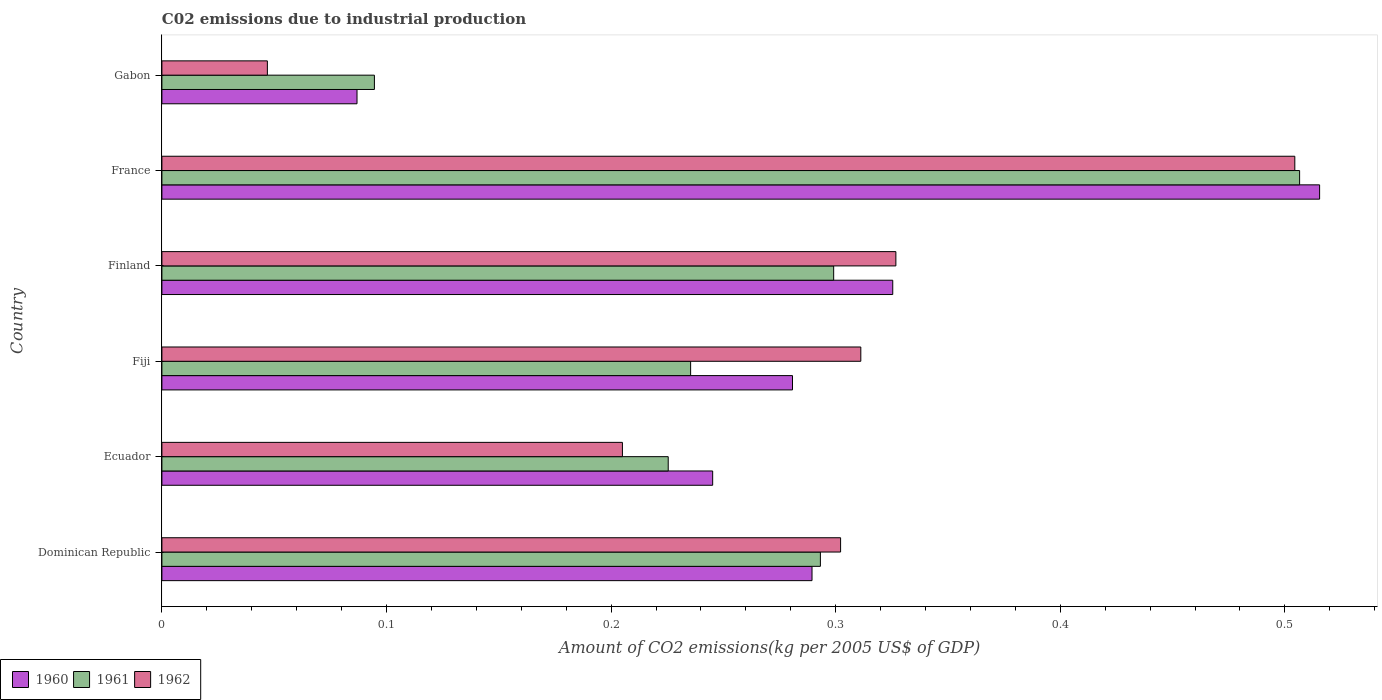How many different coloured bars are there?
Provide a short and direct response. 3. What is the label of the 4th group of bars from the top?
Provide a succinct answer. Fiji. What is the amount of CO2 emitted due to industrial production in 1961 in Finland?
Your response must be concise. 0.3. Across all countries, what is the maximum amount of CO2 emitted due to industrial production in 1962?
Your response must be concise. 0.5. Across all countries, what is the minimum amount of CO2 emitted due to industrial production in 1960?
Your answer should be compact. 0.09. In which country was the amount of CO2 emitted due to industrial production in 1962 minimum?
Offer a terse response. Gabon. What is the total amount of CO2 emitted due to industrial production in 1960 in the graph?
Make the answer very short. 1.74. What is the difference between the amount of CO2 emitted due to industrial production in 1962 in Fiji and that in Finland?
Keep it short and to the point. -0.02. What is the difference between the amount of CO2 emitted due to industrial production in 1960 in Finland and the amount of CO2 emitted due to industrial production in 1962 in Dominican Republic?
Provide a short and direct response. 0.02. What is the average amount of CO2 emitted due to industrial production in 1960 per country?
Your response must be concise. 0.29. What is the difference between the amount of CO2 emitted due to industrial production in 1960 and amount of CO2 emitted due to industrial production in 1962 in Ecuador?
Give a very brief answer. 0.04. What is the ratio of the amount of CO2 emitted due to industrial production in 1961 in Fiji to that in Gabon?
Provide a succinct answer. 2.49. Is the difference between the amount of CO2 emitted due to industrial production in 1960 in Finland and Gabon greater than the difference between the amount of CO2 emitted due to industrial production in 1962 in Finland and Gabon?
Your answer should be very brief. No. What is the difference between the highest and the second highest amount of CO2 emitted due to industrial production in 1960?
Offer a very short reply. 0.19. What is the difference between the highest and the lowest amount of CO2 emitted due to industrial production in 1960?
Your answer should be compact. 0.43. In how many countries, is the amount of CO2 emitted due to industrial production in 1962 greater than the average amount of CO2 emitted due to industrial production in 1962 taken over all countries?
Your response must be concise. 4. Is it the case that in every country, the sum of the amount of CO2 emitted due to industrial production in 1962 and amount of CO2 emitted due to industrial production in 1961 is greater than the amount of CO2 emitted due to industrial production in 1960?
Offer a very short reply. Yes. How many bars are there?
Ensure brevity in your answer.  18. What is the difference between two consecutive major ticks on the X-axis?
Give a very brief answer. 0.1. How many legend labels are there?
Provide a succinct answer. 3. How are the legend labels stacked?
Your answer should be very brief. Horizontal. What is the title of the graph?
Ensure brevity in your answer.  C02 emissions due to industrial production. What is the label or title of the X-axis?
Ensure brevity in your answer.  Amount of CO2 emissions(kg per 2005 US$ of GDP). What is the Amount of CO2 emissions(kg per 2005 US$ of GDP) of 1960 in Dominican Republic?
Ensure brevity in your answer.  0.29. What is the Amount of CO2 emissions(kg per 2005 US$ of GDP) in 1961 in Dominican Republic?
Keep it short and to the point. 0.29. What is the Amount of CO2 emissions(kg per 2005 US$ of GDP) in 1962 in Dominican Republic?
Offer a very short reply. 0.3. What is the Amount of CO2 emissions(kg per 2005 US$ of GDP) in 1960 in Ecuador?
Offer a very short reply. 0.25. What is the Amount of CO2 emissions(kg per 2005 US$ of GDP) of 1961 in Ecuador?
Give a very brief answer. 0.23. What is the Amount of CO2 emissions(kg per 2005 US$ of GDP) of 1962 in Ecuador?
Your response must be concise. 0.21. What is the Amount of CO2 emissions(kg per 2005 US$ of GDP) of 1960 in Fiji?
Keep it short and to the point. 0.28. What is the Amount of CO2 emissions(kg per 2005 US$ of GDP) in 1961 in Fiji?
Keep it short and to the point. 0.24. What is the Amount of CO2 emissions(kg per 2005 US$ of GDP) in 1962 in Fiji?
Your answer should be very brief. 0.31. What is the Amount of CO2 emissions(kg per 2005 US$ of GDP) of 1960 in Finland?
Your answer should be very brief. 0.33. What is the Amount of CO2 emissions(kg per 2005 US$ of GDP) in 1961 in Finland?
Keep it short and to the point. 0.3. What is the Amount of CO2 emissions(kg per 2005 US$ of GDP) in 1962 in Finland?
Ensure brevity in your answer.  0.33. What is the Amount of CO2 emissions(kg per 2005 US$ of GDP) in 1960 in France?
Give a very brief answer. 0.52. What is the Amount of CO2 emissions(kg per 2005 US$ of GDP) of 1961 in France?
Offer a very short reply. 0.51. What is the Amount of CO2 emissions(kg per 2005 US$ of GDP) of 1962 in France?
Offer a terse response. 0.5. What is the Amount of CO2 emissions(kg per 2005 US$ of GDP) in 1960 in Gabon?
Keep it short and to the point. 0.09. What is the Amount of CO2 emissions(kg per 2005 US$ of GDP) of 1961 in Gabon?
Provide a short and direct response. 0.09. What is the Amount of CO2 emissions(kg per 2005 US$ of GDP) of 1962 in Gabon?
Ensure brevity in your answer.  0.05. Across all countries, what is the maximum Amount of CO2 emissions(kg per 2005 US$ of GDP) in 1960?
Offer a terse response. 0.52. Across all countries, what is the maximum Amount of CO2 emissions(kg per 2005 US$ of GDP) in 1961?
Your answer should be very brief. 0.51. Across all countries, what is the maximum Amount of CO2 emissions(kg per 2005 US$ of GDP) of 1962?
Keep it short and to the point. 0.5. Across all countries, what is the minimum Amount of CO2 emissions(kg per 2005 US$ of GDP) of 1960?
Your answer should be very brief. 0.09. Across all countries, what is the minimum Amount of CO2 emissions(kg per 2005 US$ of GDP) in 1961?
Your answer should be very brief. 0.09. Across all countries, what is the minimum Amount of CO2 emissions(kg per 2005 US$ of GDP) in 1962?
Your response must be concise. 0.05. What is the total Amount of CO2 emissions(kg per 2005 US$ of GDP) of 1960 in the graph?
Offer a terse response. 1.74. What is the total Amount of CO2 emissions(kg per 2005 US$ of GDP) in 1961 in the graph?
Give a very brief answer. 1.65. What is the total Amount of CO2 emissions(kg per 2005 US$ of GDP) of 1962 in the graph?
Give a very brief answer. 1.7. What is the difference between the Amount of CO2 emissions(kg per 2005 US$ of GDP) in 1960 in Dominican Republic and that in Ecuador?
Your answer should be very brief. 0.04. What is the difference between the Amount of CO2 emissions(kg per 2005 US$ of GDP) of 1961 in Dominican Republic and that in Ecuador?
Ensure brevity in your answer.  0.07. What is the difference between the Amount of CO2 emissions(kg per 2005 US$ of GDP) of 1962 in Dominican Republic and that in Ecuador?
Your response must be concise. 0.1. What is the difference between the Amount of CO2 emissions(kg per 2005 US$ of GDP) in 1960 in Dominican Republic and that in Fiji?
Your answer should be very brief. 0.01. What is the difference between the Amount of CO2 emissions(kg per 2005 US$ of GDP) of 1961 in Dominican Republic and that in Fiji?
Your answer should be very brief. 0.06. What is the difference between the Amount of CO2 emissions(kg per 2005 US$ of GDP) of 1962 in Dominican Republic and that in Fiji?
Your response must be concise. -0.01. What is the difference between the Amount of CO2 emissions(kg per 2005 US$ of GDP) in 1960 in Dominican Republic and that in Finland?
Ensure brevity in your answer.  -0.04. What is the difference between the Amount of CO2 emissions(kg per 2005 US$ of GDP) of 1961 in Dominican Republic and that in Finland?
Provide a short and direct response. -0.01. What is the difference between the Amount of CO2 emissions(kg per 2005 US$ of GDP) of 1962 in Dominican Republic and that in Finland?
Provide a short and direct response. -0.02. What is the difference between the Amount of CO2 emissions(kg per 2005 US$ of GDP) of 1960 in Dominican Republic and that in France?
Offer a terse response. -0.23. What is the difference between the Amount of CO2 emissions(kg per 2005 US$ of GDP) of 1961 in Dominican Republic and that in France?
Keep it short and to the point. -0.21. What is the difference between the Amount of CO2 emissions(kg per 2005 US$ of GDP) in 1962 in Dominican Republic and that in France?
Keep it short and to the point. -0.2. What is the difference between the Amount of CO2 emissions(kg per 2005 US$ of GDP) in 1960 in Dominican Republic and that in Gabon?
Your response must be concise. 0.2. What is the difference between the Amount of CO2 emissions(kg per 2005 US$ of GDP) of 1961 in Dominican Republic and that in Gabon?
Provide a succinct answer. 0.2. What is the difference between the Amount of CO2 emissions(kg per 2005 US$ of GDP) of 1962 in Dominican Republic and that in Gabon?
Keep it short and to the point. 0.26. What is the difference between the Amount of CO2 emissions(kg per 2005 US$ of GDP) of 1960 in Ecuador and that in Fiji?
Provide a short and direct response. -0.04. What is the difference between the Amount of CO2 emissions(kg per 2005 US$ of GDP) of 1961 in Ecuador and that in Fiji?
Your answer should be very brief. -0.01. What is the difference between the Amount of CO2 emissions(kg per 2005 US$ of GDP) in 1962 in Ecuador and that in Fiji?
Your response must be concise. -0.11. What is the difference between the Amount of CO2 emissions(kg per 2005 US$ of GDP) of 1960 in Ecuador and that in Finland?
Provide a short and direct response. -0.08. What is the difference between the Amount of CO2 emissions(kg per 2005 US$ of GDP) in 1961 in Ecuador and that in Finland?
Your response must be concise. -0.07. What is the difference between the Amount of CO2 emissions(kg per 2005 US$ of GDP) of 1962 in Ecuador and that in Finland?
Your answer should be very brief. -0.12. What is the difference between the Amount of CO2 emissions(kg per 2005 US$ of GDP) of 1960 in Ecuador and that in France?
Make the answer very short. -0.27. What is the difference between the Amount of CO2 emissions(kg per 2005 US$ of GDP) of 1961 in Ecuador and that in France?
Make the answer very short. -0.28. What is the difference between the Amount of CO2 emissions(kg per 2005 US$ of GDP) of 1962 in Ecuador and that in France?
Your answer should be very brief. -0.3. What is the difference between the Amount of CO2 emissions(kg per 2005 US$ of GDP) of 1960 in Ecuador and that in Gabon?
Give a very brief answer. 0.16. What is the difference between the Amount of CO2 emissions(kg per 2005 US$ of GDP) in 1961 in Ecuador and that in Gabon?
Keep it short and to the point. 0.13. What is the difference between the Amount of CO2 emissions(kg per 2005 US$ of GDP) of 1962 in Ecuador and that in Gabon?
Provide a short and direct response. 0.16. What is the difference between the Amount of CO2 emissions(kg per 2005 US$ of GDP) in 1960 in Fiji and that in Finland?
Keep it short and to the point. -0.04. What is the difference between the Amount of CO2 emissions(kg per 2005 US$ of GDP) of 1961 in Fiji and that in Finland?
Ensure brevity in your answer.  -0.06. What is the difference between the Amount of CO2 emissions(kg per 2005 US$ of GDP) of 1962 in Fiji and that in Finland?
Your answer should be very brief. -0.02. What is the difference between the Amount of CO2 emissions(kg per 2005 US$ of GDP) of 1960 in Fiji and that in France?
Offer a very short reply. -0.23. What is the difference between the Amount of CO2 emissions(kg per 2005 US$ of GDP) of 1961 in Fiji and that in France?
Ensure brevity in your answer.  -0.27. What is the difference between the Amount of CO2 emissions(kg per 2005 US$ of GDP) in 1962 in Fiji and that in France?
Keep it short and to the point. -0.19. What is the difference between the Amount of CO2 emissions(kg per 2005 US$ of GDP) of 1960 in Fiji and that in Gabon?
Ensure brevity in your answer.  0.19. What is the difference between the Amount of CO2 emissions(kg per 2005 US$ of GDP) in 1961 in Fiji and that in Gabon?
Provide a succinct answer. 0.14. What is the difference between the Amount of CO2 emissions(kg per 2005 US$ of GDP) of 1962 in Fiji and that in Gabon?
Offer a terse response. 0.26. What is the difference between the Amount of CO2 emissions(kg per 2005 US$ of GDP) of 1960 in Finland and that in France?
Ensure brevity in your answer.  -0.19. What is the difference between the Amount of CO2 emissions(kg per 2005 US$ of GDP) in 1961 in Finland and that in France?
Offer a terse response. -0.21. What is the difference between the Amount of CO2 emissions(kg per 2005 US$ of GDP) of 1962 in Finland and that in France?
Ensure brevity in your answer.  -0.18. What is the difference between the Amount of CO2 emissions(kg per 2005 US$ of GDP) in 1960 in Finland and that in Gabon?
Your answer should be very brief. 0.24. What is the difference between the Amount of CO2 emissions(kg per 2005 US$ of GDP) in 1961 in Finland and that in Gabon?
Provide a succinct answer. 0.2. What is the difference between the Amount of CO2 emissions(kg per 2005 US$ of GDP) of 1962 in Finland and that in Gabon?
Provide a succinct answer. 0.28. What is the difference between the Amount of CO2 emissions(kg per 2005 US$ of GDP) in 1960 in France and that in Gabon?
Offer a terse response. 0.43. What is the difference between the Amount of CO2 emissions(kg per 2005 US$ of GDP) in 1961 in France and that in Gabon?
Make the answer very short. 0.41. What is the difference between the Amount of CO2 emissions(kg per 2005 US$ of GDP) of 1962 in France and that in Gabon?
Ensure brevity in your answer.  0.46. What is the difference between the Amount of CO2 emissions(kg per 2005 US$ of GDP) of 1960 in Dominican Republic and the Amount of CO2 emissions(kg per 2005 US$ of GDP) of 1961 in Ecuador?
Keep it short and to the point. 0.06. What is the difference between the Amount of CO2 emissions(kg per 2005 US$ of GDP) in 1960 in Dominican Republic and the Amount of CO2 emissions(kg per 2005 US$ of GDP) in 1962 in Ecuador?
Offer a very short reply. 0.08. What is the difference between the Amount of CO2 emissions(kg per 2005 US$ of GDP) of 1961 in Dominican Republic and the Amount of CO2 emissions(kg per 2005 US$ of GDP) of 1962 in Ecuador?
Give a very brief answer. 0.09. What is the difference between the Amount of CO2 emissions(kg per 2005 US$ of GDP) in 1960 in Dominican Republic and the Amount of CO2 emissions(kg per 2005 US$ of GDP) in 1961 in Fiji?
Offer a very short reply. 0.05. What is the difference between the Amount of CO2 emissions(kg per 2005 US$ of GDP) in 1960 in Dominican Republic and the Amount of CO2 emissions(kg per 2005 US$ of GDP) in 1962 in Fiji?
Provide a short and direct response. -0.02. What is the difference between the Amount of CO2 emissions(kg per 2005 US$ of GDP) of 1961 in Dominican Republic and the Amount of CO2 emissions(kg per 2005 US$ of GDP) of 1962 in Fiji?
Ensure brevity in your answer.  -0.02. What is the difference between the Amount of CO2 emissions(kg per 2005 US$ of GDP) of 1960 in Dominican Republic and the Amount of CO2 emissions(kg per 2005 US$ of GDP) of 1961 in Finland?
Keep it short and to the point. -0.01. What is the difference between the Amount of CO2 emissions(kg per 2005 US$ of GDP) of 1960 in Dominican Republic and the Amount of CO2 emissions(kg per 2005 US$ of GDP) of 1962 in Finland?
Your response must be concise. -0.04. What is the difference between the Amount of CO2 emissions(kg per 2005 US$ of GDP) in 1961 in Dominican Republic and the Amount of CO2 emissions(kg per 2005 US$ of GDP) in 1962 in Finland?
Offer a terse response. -0.03. What is the difference between the Amount of CO2 emissions(kg per 2005 US$ of GDP) in 1960 in Dominican Republic and the Amount of CO2 emissions(kg per 2005 US$ of GDP) in 1961 in France?
Give a very brief answer. -0.22. What is the difference between the Amount of CO2 emissions(kg per 2005 US$ of GDP) of 1960 in Dominican Republic and the Amount of CO2 emissions(kg per 2005 US$ of GDP) of 1962 in France?
Offer a very short reply. -0.21. What is the difference between the Amount of CO2 emissions(kg per 2005 US$ of GDP) in 1961 in Dominican Republic and the Amount of CO2 emissions(kg per 2005 US$ of GDP) in 1962 in France?
Offer a very short reply. -0.21. What is the difference between the Amount of CO2 emissions(kg per 2005 US$ of GDP) in 1960 in Dominican Republic and the Amount of CO2 emissions(kg per 2005 US$ of GDP) in 1961 in Gabon?
Ensure brevity in your answer.  0.19. What is the difference between the Amount of CO2 emissions(kg per 2005 US$ of GDP) of 1960 in Dominican Republic and the Amount of CO2 emissions(kg per 2005 US$ of GDP) of 1962 in Gabon?
Ensure brevity in your answer.  0.24. What is the difference between the Amount of CO2 emissions(kg per 2005 US$ of GDP) of 1961 in Dominican Republic and the Amount of CO2 emissions(kg per 2005 US$ of GDP) of 1962 in Gabon?
Your response must be concise. 0.25. What is the difference between the Amount of CO2 emissions(kg per 2005 US$ of GDP) of 1960 in Ecuador and the Amount of CO2 emissions(kg per 2005 US$ of GDP) of 1961 in Fiji?
Provide a short and direct response. 0.01. What is the difference between the Amount of CO2 emissions(kg per 2005 US$ of GDP) in 1960 in Ecuador and the Amount of CO2 emissions(kg per 2005 US$ of GDP) in 1962 in Fiji?
Your answer should be compact. -0.07. What is the difference between the Amount of CO2 emissions(kg per 2005 US$ of GDP) in 1961 in Ecuador and the Amount of CO2 emissions(kg per 2005 US$ of GDP) in 1962 in Fiji?
Ensure brevity in your answer.  -0.09. What is the difference between the Amount of CO2 emissions(kg per 2005 US$ of GDP) of 1960 in Ecuador and the Amount of CO2 emissions(kg per 2005 US$ of GDP) of 1961 in Finland?
Offer a terse response. -0.05. What is the difference between the Amount of CO2 emissions(kg per 2005 US$ of GDP) of 1960 in Ecuador and the Amount of CO2 emissions(kg per 2005 US$ of GDP) of 1962 in Finland?
Your answer should be compact. -0.08. What is the difference between the Amount of CO2 emissions(kg per 2005 US$ of GDP) of 1961 in Ecuador and the Amount of CO2 emissions(kg per 2005 US$ of GDP) of 1962 in Finland?
Your answer should be very brief. -0.1. What is the difference between the Amount of CO2 emissions(kg per 2005 US$ of GDP) in 1960 in Ecuador and the Amount of CO2 emissions(kg per 2005 US$ of GDP) in 1961 in France?
Provide a succinct answer. -0.26. What is the difference between the Amount of CO2 emissions(kg per 2005 US$ of GDP) of 1960 in Ecuador and the Amount of CO2 emissions(kg per 2005 US$ of GDP) of 1962 in France?
Your answer should be compact. -0.26. What is the difference between the Amount of CO2 emissions(kg per 2005 US$ of GDP) of 1961 in Ecuador and the Amount of CO2 emissions(kg per 2005 US$ of GDP) of 1962 in France?
Your answer should be very brief. -0.28. What is the difference between the Amount of CO2 emissions(kg per 2005 US$ of GDP) of 1960 in Ecuador and the Amount of CO2 emissions(kg per 2005 US$ of GDP) of 1961 in Gabon?
Ensure brevity in your answer.  0.15. What is the difference between the Amount of CO2 emissions(kg per 2005 US$ of GDP) in 1960 in Ecuador and the Amount of CO2 emissions(kg per 2005 US$ of GDP) in 1962 in Gabon?
Keep it short and to the point. 0.2. What is the difference between the Amount of CO2 emissions(kg per 2005 US$ of GDP) of 1961 in Ecuador and the Amount of CO2 emissions(kg per 2005 US$ of GDP) of 1962 in Gabon?
Give a very brief answer. 0.18. What is the difference between the Amount of CO2 emissions(kg per 2005 US$ of GDP) of 1960 in Fiji and the Amount of CO2 emissions(kg per 2005 US$ of GDP) of 1961 in Finland?
Give a very brief answer. -0.02. What is the difference between the Amount of CO2 emissions(kg per 2005 US$ of GDP) in 1960 in Fiji and the Amount of CO2 emissions(kg per 2005 US$ of GDP) in 1962 in Finland?
Offer a terse response. -0.05. What is the difference between the Amount of CO2 emissions(kg per 2005 US$ of GDP) of 1961 in Fiji and the Amount of CO2 emissions(kg per 2005 US$ of GDP) of 1962 in Finland?
Keep it short and to the point. -0.09. What is the difference between the Amount of CO2 emissions(kg per 2005 US$ of GDP) in 1960 in Fiji and the Amount of CO2 emissions(kg per 2005 US$ of GDP) in 1961 in France?
Give a very brief answer. -0.23. What is the difference between the Amount of CO2 emissions(kg per 2005 US$ of GDP) of 1960 in Fiji and the Amount of CO2 emissions(kg per 2005 US$ of GDP) of 1962 in France?
Offer a terse response. -0.22. What is the difference between the Amount of CO2 emissions(kg per 2005 US$ of GDP) in 1961 in Fiji and the Amount of CO2 emissions(kg per 2005 US$ of GDP) in 1962 in France?
Ensure brevity in your answer.  -0.27. What is the difference between the Amount of CO2 emissions(kg per 2005 US$ of GDP) in 1960 in Fiji and the Amount of CO2 emissions(kg per 2005 US$ of GDP) in 1961 in Gabon?
Give a very brief answer. 0.19. What is the difference between the Amount of CO2 emissions(kg per 2005 US$ of GDP) in 1960 in Fiji and the Amount of CO2 emissions(kg per 2005 US$ of GDP) in 1962 in Gabon?
Offer a terse response. 0.23. What is the difference between the Amount of CO2 emissions(kg per 2005 US$ of GDP) in 1961 in Fiji and the Amount of CO2 emissions(kg per 2005 US$ of GDP) in 1962 in Gabon?
Your response must be concise. 0.19. What is the difference between the Amount of CO2 emissions(kg per 2005 US$ of GDP) of 1960 in Finland and the Amount of CO2 emissions(kg per 2005 US$ of GDP) of 1961 in France?
Give a very brief answer. -0.18. What is the difference between the Amount of CO2 emissions(kg per 2005 US$ of GDP) in 1960 in Finland and the Amount of CO2 emissions(kg per 2005 US$ of GDP) in 1962 in France?
Keep it short and to the point. -0.18. What is the difference between the Amount of CO2 emissions(kg per 2005 US$ of GDP) in 1961 in Finland and the Amount of CO2 emissions(kg per 2005 US$ of GDP) in 1962 in France?
Provide a short and direct response. -0.21. What is the difference between the Amount of CO2 emissions(kg per 2005 US$ of GDP) of 1960 in Finland and the Amount of CO2 emissions(kg per 2005 US$ of GDP) of 1961 in Gabon?
Provide a short and direct response. 0.23. What is the difference between the Amount of CO2 emissions(kg per 2005 US$ of GDP) in 1960 in Finland and the Amount of CO2 emissions(kg per 2005 US$ of GDP) in 1962 in Gabon?
Ensure brevity in your answer.  0.28. What is the difference between the Amount of CO2 emissions(kg per 2005 US$ of GDP) in 1961 in Finland and the Amount of CO2 emissions(kg per 2005 US$ of GDP) in 1962 in Gabon?
Provide a short and direct response. 0.25. What is the difference between the Amount of CO2 emissions(kg per 2005 US$ of GDP) of 1960 in France and the Amount of CO2 emissions(kg per 2005 US$ of GDP) of 1961 in Gabon?
Your response must be concise. 0.42. What is the difference between the Amount of CO2 emissions(kg per 2005 US$ of GDP) in 1960 in France and the Amount of CO2 emissions(kg per 2005 US$ of GDP) in 1962 in Gabon?
Provide a short and direct response. 0.47. What is the difference between the Amount of CO2 emissions(kg per 2005 US$ of GDP) of 1961 in France and the Amount of CO2 emissions(kg per 2005 US$ of GDP) of 1962 in Gabon?
Give a very brief answer. 0.46. What is the average Amount of CO2 emissions(kg per 2005 US$ of GDP) in 1960 per country?
Offer a terse response. 0.29. What is the average Amount of CO2 emissions(kg per 2005 US$ of GDP) in 1961 per country?
Keep it short and to the point. 0.28. What is the average Amount of CO2 emissions(kg per 2005 US$ of GDP) in 1962 per country?
Give a very brief answer. 0.28. What is the difference between the Amount of CO2 emissions(kg per 2005 US$ of GDP) in 1960 and Amount of CO2 emissions(kg per 2005 US$ of GDP) in 1961 in Dominican Republic?
Your answer should be compact. -0. What is the difference between the Amount of CO2 emissions(kg per 2005 US$ of GDP) in 1960 and Amount of CO2 emissions(kg per 2005 US$ of GDP) in 1962 in Dominican Republic?
Offer a terse response. -0.01. What is the difference between the Amount of CO2 emissions(kg per 2005 US$ of GDP) of 1961 and Amount of CO2 emissions(kg per 2005 US$ of GDP) of 1962 in Dominican Republic?
Ensure brevity in your answer.  -0.01. What is the difference between the Amount of CO2 emissions(kg per 2005 US$ of GDP) of 1960 and Amount of CO2 emissions(kg per 2005 US$ of GDP) of 1961 in Ecuador?
Ensure brevity in your answer.  0.02. What is the difference between the Amount of CO2 emissions(kg per 2005 US$ of GDP) in 1960 and Amount of CO2 emissions(kg per 2005 US$ of GDP) in 1962 in Ecuador?
Give a very brief answer. 0.04. What is the difference between the Amount of CO2 emissions(kg per 2005 US$ of GDP) in 1961 and Amount of CO2 emissions(kg per 2005 US$ of GDP) in 1962 in Ecuador?
Keep it short and to the point. 0.02. What is the difference between the Amount of CO2 emissions(kg per 2005 US$ of GDP) of 1960 and Amount of CO2 emissions(kg per 2005 US$ of GDP) of 1961 in Fiji?
Offer a terse response. 0.05. What is the difference between the Amount of CO2 emissions(kg per 2005 US$ of GDP) of 1960 and Amount of CO2 emissions(kg per 2005 US$ of GDP) of 1962 in Fiji?
Make the answer very short. -0.03. What is the difference between the Amount of CO2 emissions(kg per 2005 US$ of GDP) of 1961 and Amount of CO2 emissions(kg per 2005 US$ of GDP) of 1962 in Fiji?
Make the answer very short. -0.08. What is the difference between the Amount of CO2 emissions(kg per 2005 US$ of GDP) in 1960 and Amount of CO2 emissions(kg per 2005 US$ of GDP) in 1961 in Finland?
Provide a short and direct response. 0.03. What is the difference between the Amount of CO2 emissions(kg per 2005 US$ of GDP) in 1960 and Amount of CO2 emissions(kg per 2005 US$ of GDP) in 1962 in Finland?
Offer a terse response. -0. What is the difference between the Amount of CO2 emissions(kg per 2005 US$ of GDP) of 1961 and Amount of CO2 emissions(kg per 2005 US$ of GDP) of 1962 in Finland?
Offer a very short reply. -0.03. What is the difference between the Amount of CO2 emissions(kg per 2005 US$ of GDP) in 1960 and Amount of CO2 emissions(kg per 2005 US$ of GDP) in 1961 in France?
Your answer should be very brief. 0.01. What is the difference between the Amount of CO2 emissions(kg per 2005 US$ of GDP) of 1960 and Amount of CO2 emissions(kg per 2005 US$ of GDP) of 1962 in France?
Offer a very short reply. 0.01. What is the difference between the Amount of CO2 emissions(kg per 2005 US$ of GDP) in 1961 and Amount of CO2 emissions(kg per 2005 US$ of GDP) in 1962 in France?
Your answer should be very brief. 0. What is the difference between the Amount of CO2 emissions(kg per 2005 US$ of GDP) in 1960 and Amount of CO2 emissions(kg per 2005 US$ of GDP) in 1961 in Gabon?
Ensure brevity in your answer.  -0.01. What is the difference between the Amount of CO2 emissions(kg per 2005 US$ of GDP) in 1960 and Amount of CO2 emissions(kg per 2005 US$ of GDP) in 1962 in Gabon?
Your response must be concise. 0.04. What is the difference between the Amount of CO2 emissions(kg per 2005 US$ of GDP) of 1961 and Amount of CO2 emissions(kg per 2005 US$ of GDP) of 1962 in Gabon?
Offer a very short reply. 0.05. What is the ratio of the Amount of CO2 emissions(kg per 2005 US$ of GDP) in 1960 in Dominican Republic to that in Ecuador?
Your answer should be very brief. 1.18. What is the ratio of the Amount of CO2 emissions(kg per 2005 US$ of GDP) in 1961 in Dominican Republic to that in Ecuador?
Make the answer very short. 1.3. What is the ratio of the Amount of CO2 emissions(kg per 2005 US$ of GDP) of 1962 in Dominican Republic to that in Ecuador?
Offer a terse response. 1.47. What is the ratio of the Amount of CO2 emissions(kg per 2005 US$ of GDP) in 1960 in Dominican Republic to that in Fiji?
Your answer should be very brief. 1.03. What is the ratio of the Amount of CO2 emissions(kg per 2005 US$ of GDP) in 1961 in Dominican Republic to that in Fiji?
Offer a very short reply. 1.25. What is the ratio of the Amount of CO2 emissions(kg per 2005 US$ of GDP) in 1962 in Dominican Republic to that in Fiji?
Make the answer very short. 0.97. What is the ratio of the Amount of CO2 emissions(kg per 2005 US$ of GDP) of 1960 in Dominican Republic to that in Finland?
Offer a terse response. 0.89. What is the ratio of the Amount of CO2 emissions(kg per 2005 US$ of GDP) of 1961 in Dominican Republic to that in Finland?
Provide a succinct answer. 0.98. What is the ratio of the Amount of CO2 emissions(kg per 2005 US$ of GDP) in 1962 in Dominican Republic to that in Finland?
Keep it short and to the point. 0.92. What is the ratio of the Amount of CO2 emissions(kg per 2005 US$ of GDP) in 1960 in Dominican Republic to that in France?
Give a very brief answer. 0.56. What is the ratio of the Amount of CO2 emissions(kg per 2005 US$ of GDP) of 1961 in Dominican Republic to that in France?
Offer a very short reply. 0.58. What is the ratio of the Amount of CO2 emissions(kg per 2005 US$ of GDP) in 1962 in Dominican Republic to that in France?
Your response must be concise. 0.6. What is the ratio of the Amount of CO2 emissions(kg per 2005 US$ of GDP) of 1960 in Dominican Republic to that in Gabon?
Your response must be concise. 3.33. What is the ratio of the Amount of CO2 emissions(kg per 2005 US$ of GDP) in 1961 in Dominican Republic to that in Gabon?
Make the answer very short. 3.1. What is the ratio of the Amount of CO2 emissions(kg per 2005 US$ of GDP) of 1962 in Dominican Republic to that in Gabon?
Make the answer very short. 6.43. What is the ratio of the Amount of CO2 emissions(kg per 2005 US$ of GDP) in 1960 in Ecuador to that in Fiji?
Your answer should be very brief. 0.87. What is the ratio of the Amount of CO2 emissions(kg per 2005 US$ of GDP) in 1961 in Ecuador to that in Fiji?
Ensure brevity in your answer.  0.96. What is the ratio of the Amount of CO2 emissions(kg per 2005 US$ of GDP) in 1962 in Ecuador to that in Fiji?
Give a very brief answer. 0.66. What is the ratio of the Amount of CO2 emissions(kg per 2005 US$ of GDP) in 1960 in Ecuador to that in Finland?
Provide a succinct answer. 0.75. What is the ratio of the Amount of CO2 emissions(kg per 2005 US$ of GDP) in 1961 in Ecuador to that in Finland?
Provide a short and direct response. 0.75. What is the ratio of the Amount of CO2 emissions(kg per 2005 US$ of GDP) of 1962 in Ecuador to that in Finland?
Give a very brief answer. 0.63. What is the ratio of the Amount of CO2 emissions(kg per 2005 US$ of GDP) in 1960 in Ecuador to that in France?
Offer a terse response. 0.48. What is the ratio of the Amount of CO2 emissions(kg per 2005 US$ of GDP) in 1961 in Ecuador to that in France?
Your response must be concise. 0.45. What is the ratio of the Amount of CO2 emissions(kg per 2005 US$ of GDP) of 1962 in Ecuador to that in France?
Provide a short and direct response. 0.41. What is the ratio of the Amount of CO2 emissions(kg per 2005 US$ of GDP) in 1960 in Ecuador to that in Gabon?
Make the answer very short. 2.82. What is the ratio of the Amount of CO2 emissions(kg per 2005 US$ of GDP) of 1961 in Ecuador to that in Gabon?
Make the answer very short. 2.38. What is the ratio of the Amount of CO2 emissions(kg per 2005 US$ of GDP) in 1962 in Ecuador to that in Gabon?
Keep it short and to the point. 4.37. What is the ratio of the Amount of CO2 emissions(kg per 2005 US$ of GDP) of 1960 in Fiji to that in Finland?
Offer a terse response. 0.86. What is the ratio of the Amount of CO2 emissions(kg per 2005 US$ of GDP) in 1961 in Fiji to that in Finland?
Offer a very short reply. 0.79. What is the ratio of the Amount of CO2 emissions(kg per 2005 US$ of GDP) of 1962 in Fiji to that in Finland?
Offer a very short reply. 0.95. What is the ratio of the Amount of CO2 emissions(kg per 2005 US$ of GDP) of 1960 in Fiji to that in France?
Your answer should be very brief. 0.54. What is the ratio of the Amount of CO2 emissions(kg per 2005 US$ of GDP) of 1961 in Fiji to that in France?
Your response must be concise. 0.46. What is the ratio of the Amount of CO2 emissions(kg per 2005 US$ of GDP) in 1962 in Fiji to that in France?
Keep it short and to the point. 0.62. What is the ratio of the Amount of CO2 emissions(kg per 2005 US$ of GDP) of 1960 in Fiji to that in Gabon?
Give a very brief answer. 3.23. What is the ratio of the Amount of CO2 emissions(kg per 2005 US$ of GDP) of 1961 in Fiji to that in Gabon?
Keep it short and to the point. 2.49. What is the ratio of the Amount of CO2 emissions(kg per 2005 US$ of GDP) in 1962 in Fiji to that in Gabon?
Provide a short and direct response. 6.63. What is the ratio of the Amount of CO2 emissions(kg per 2005 US$ of GDP) of 1960 in Finland to that in France?
Keep it short and to the point. 0.63. What is the ratio of the Amount of CO2 emissions(kg per 2005 US$ of GDP) in 1961 in Finland to that in France?
Keep it short and to the point. 0.59. What is the ratio of the Amount of CO2 emissions(kg per 2005 US$ of GDP) in 1962 in Finland to that in France?
Your answer should be very brief. 0.65. What is the ratio of the Amount of CO2 emissions(kg per 2005 US$ of GDP) of 1960 in Finland to that in Gabon?
Give a very brief answer. 3.75. What is the ratio of the Amount of CO2 emissions(kg per 2005 US$ of GDP) of 1961 in Finland to that in Gabon?
Your answer should be very brief. 3.16. What is the ratio of the Amount of CO2 emissions(kg per 2005 US$ of GDP) of 1962 in Finland to that in Gabon?
Make the answer very short. 6.96. What is the ratio of the Amount of CO2 emissions(kg per 2005 US$ of GDP) in 1960 in France to that in Gabon?
Your response must be concise. 5.93. What is the ratio of the Amount of CO2 emissions(kg per 2005 US$ of GDP) in 1961 in France to that in Gabon?
Keep it short and to the point. 5.35. What is the ratio of the Amount of CO2 emissions(kg per 2005 US$ of GDP) of 1962 in France to that in Gabon?
Provide a succinct answer. 10.74. What is the difference between the highest and the second highest Amount of CO2 emissions(kg per 2005 US$ of GDP) in 1960?
Make the answer very short. 0.19. What is the difference between the highest and the second highest Amount of CO2 emissions(kg per 2005 US$ of GDP) of 1961?
Provide a succinct answer. 0.21. What is the difference between the highest and the second highest Amount of CO2 emissions(kg per 2005 US$ of GDP) of 1962?
Ensure brevity in your answer.  0.18. What is the difference between the highest and the lowest Amount of CO2 emissions(kg per 2005 US$ of GDP) in 1960?
Your answer should be compact. 0.43. What is the difference between the highest and the lowest Amount of CO2 emissions(kg per 2005 US$ of GDP) of 1961?
Offer a very short reply. 0.41. What is the difference between the highest and the lowest Amount of CO2 emissions(kg per 2005 US$ of GDP) in 1962?
Your response must be concise. 0.46. 